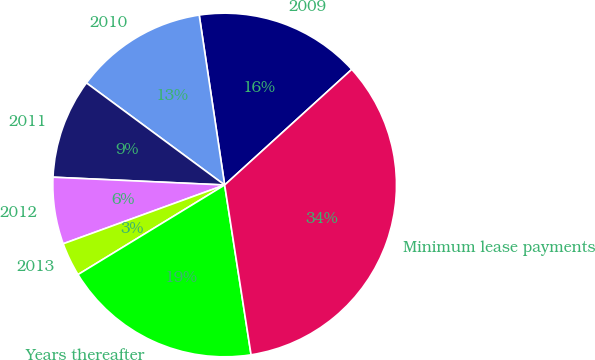Convert chart to OTSL. <chart><loc_0><loc_0><loc_500><loc_500><pie_chart><fcel>2009<fcel>2010<fcel>2011<fcel>2012<fcel>2013<fcel>Years thereafter<fcel>Minimum lease payments<nl><fcel>15.62%<fcel>12.51%<fcel>9.4%<fcel>6.28%<fcel>3.17%<fcel>18.73%<fcel>34.29%<nl></chart> 